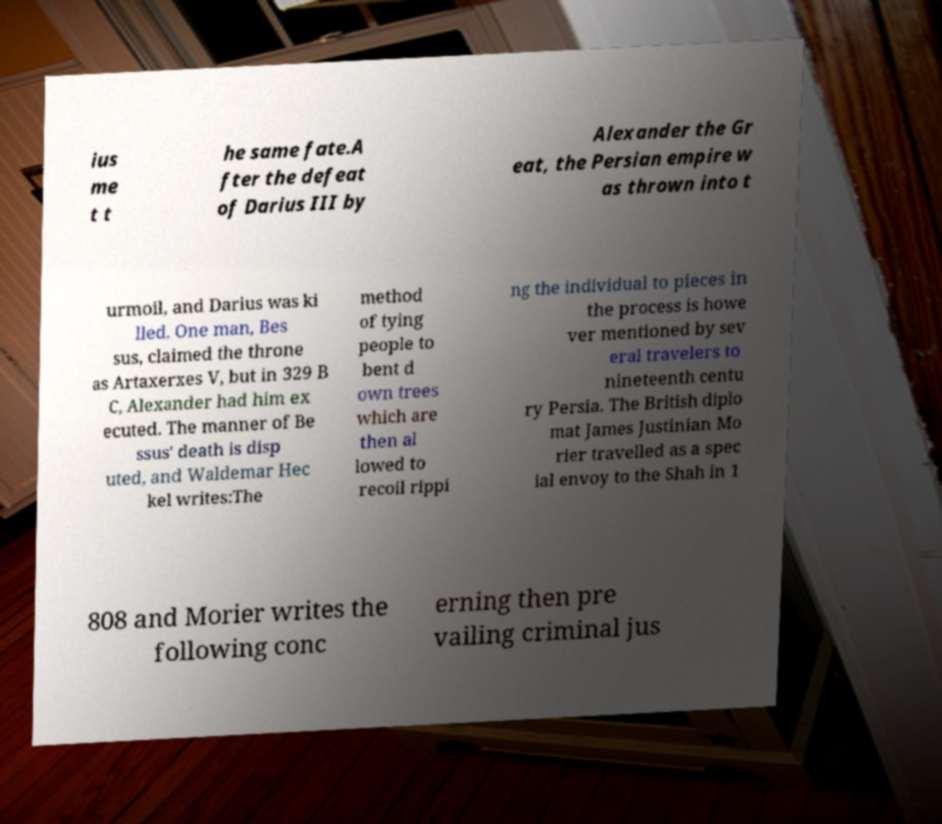I need the written content from this picture converted into text. Can you do that? ius me t t he same fate.A fter the defeat of Darius III by Alexander the Gr eat, the Persian empire w as thrown into t urmoil, and Darius was ki lled. One man, Bes sus, claimed the throne as Artaxerxes V, but in 329 B C, Alexander had him ex ecuted. The manner of Be ssus' death is disp uted, and Waldemar Hec kel writes:The method of tying people to bent d own trees which are then al lowed to recoil rippi ng the individual to pieces in the process is howe ver mentioned by sev eral travelers to nineteenth centu ry Persia. The British diplo mat James Justinian Mo rier travelled as a spec ial envoy to the Shah in 1 808 and Morier writes the following conc erning then pre vailing criminal jus 